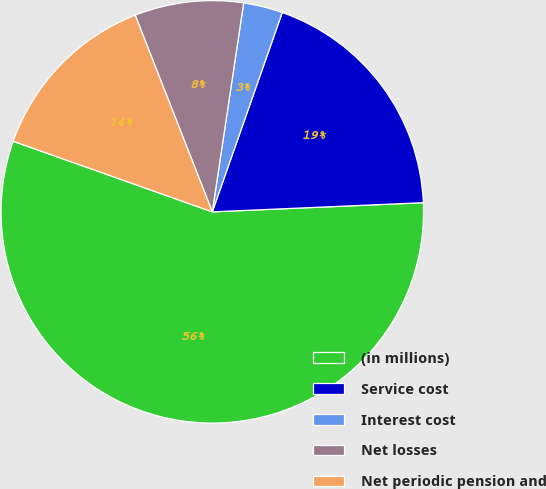Convert chart to OTSL. <chart><loc_0><loc_0><loc_500><loc_500><pie_chart><fcel>(in millions)<fcel>Service cost<fcel>Interest cost<fcel>Net losses<fcel>Net periodic pension and<nl><fcel>56.12%<fcel>18.94%<fcel>3.0%<fcel>8.32%<fcel>13.63%<nl></chart> 